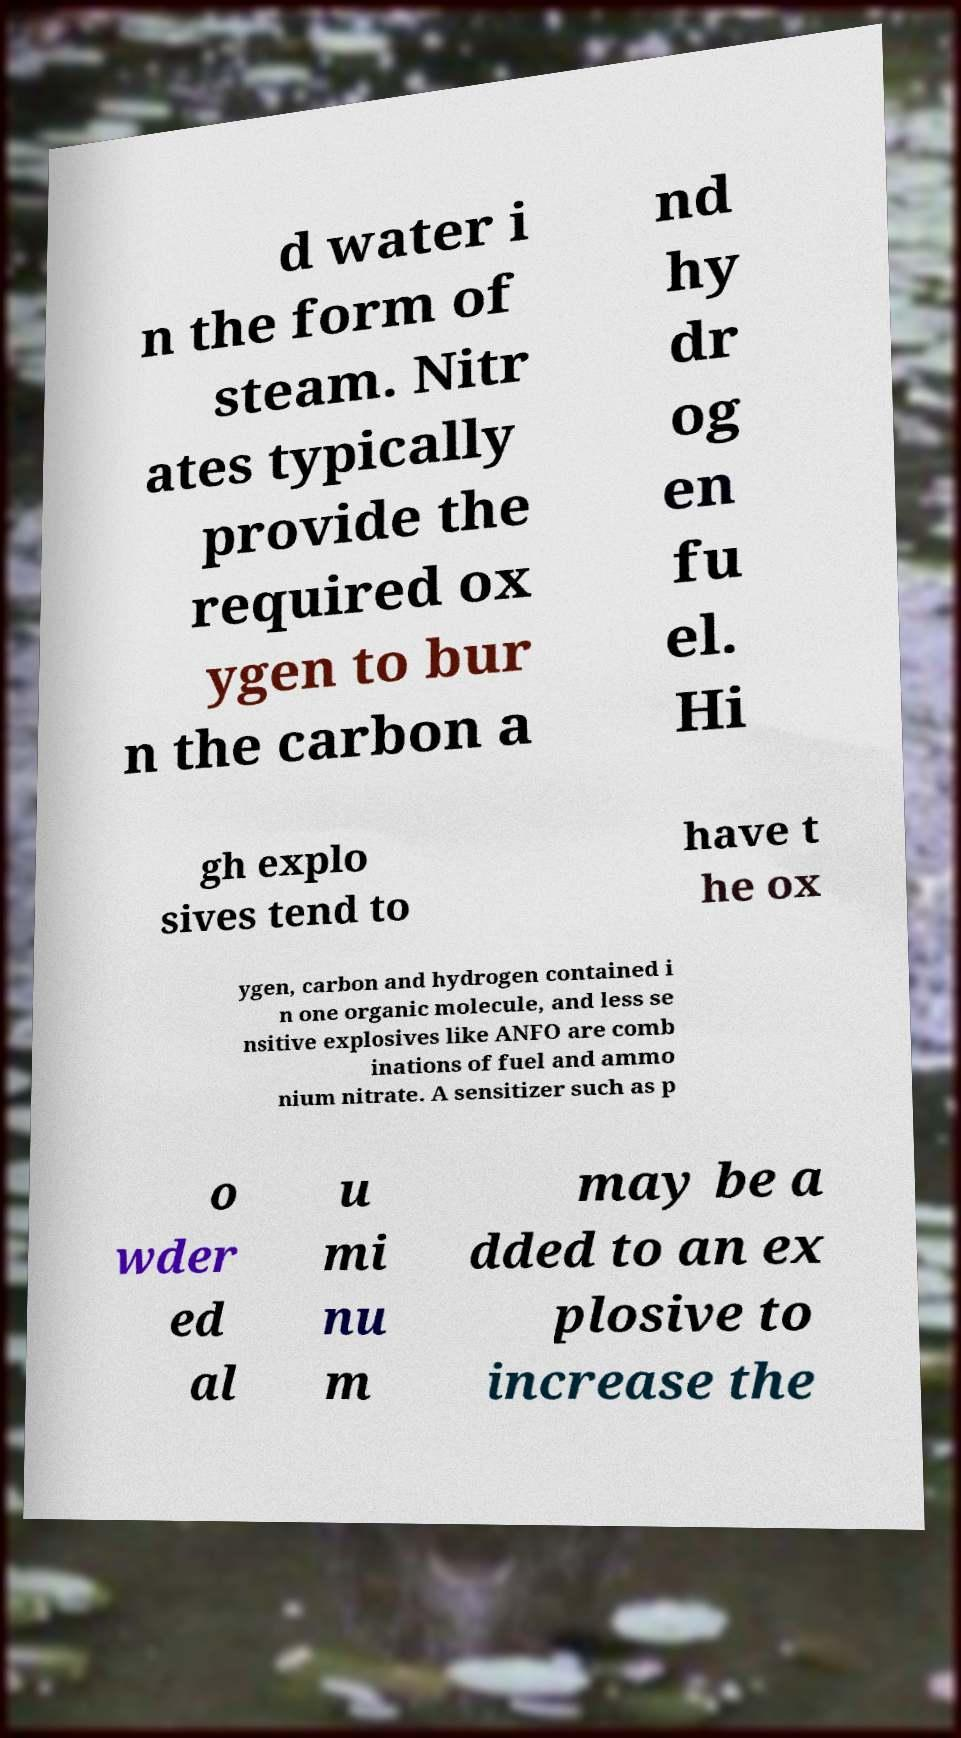Can you read and provide the text displayed in the image?This photo seems to have some interesting text. Can you extract and type it out for me? d water i n the form of steam. Nitr ates typically provide the required ox ygen to bur n the carbon a nd hy dr og en fu el. Hi gh explo sives tend to have t he ox ygen, carbon and hydrogen contained i n one organic molecule, and less se nsitive explosives like ANFO are comb inations of fuel and ammo nium nitrate. A sensitizer such as p o wder ed al u mi nu m may be a dded to an ex plosive to increase the 